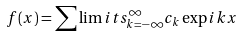<formula> <loc_0><loc_0><loc_500><loc_500>f ( x ) = \sum \lim i t s _ { k = - \infty } ^ { \infty } c _ { k } \exp i k x</formula> 